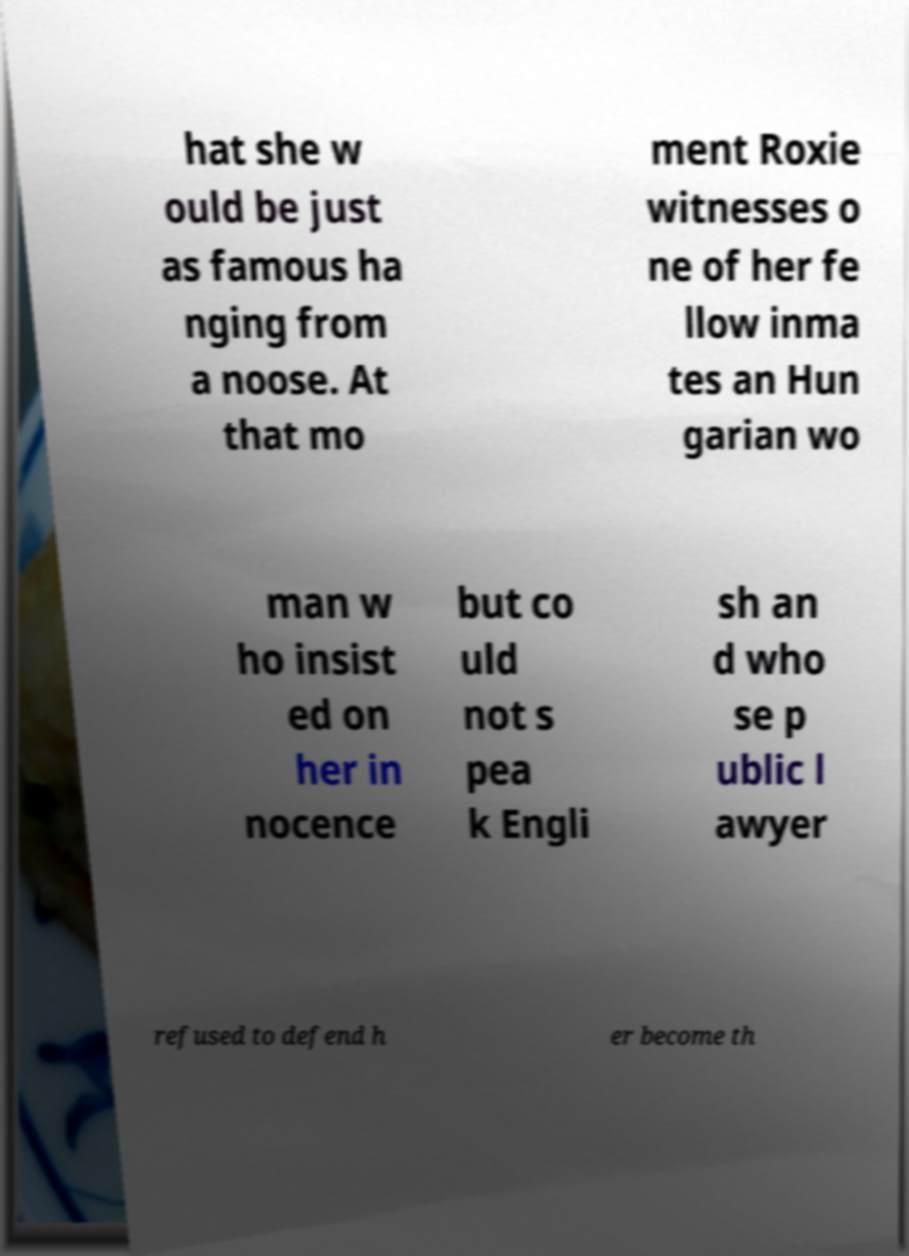Could you assist in decoding the text presented in this image and type it out clearly? hat she w ould be just as famous ha nging from a noose. At that mo ment Roxie witnesses o ne of her fe llow inma tes an Hun garian wo man w ho insist ed on her in nocence but co uld not s pea k Engli sh an d who se p ublic l awyer refused to defend h er become th 